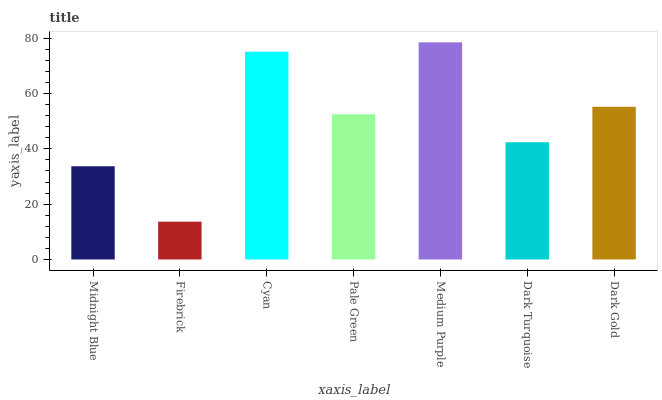Is Firebrick the minimum?
Answer yes or no. Yes. Is Medium Purple the maximum?
Answer yes or no. Yes. Is Cyan the minimum?
Answer yes or no. No. Is Cyan the maximum?
Answer yes or no. No. Is Cyan greater than Firebrick?
Answer yes or no. Yes. Is Firebrick less than Cyan?
Answer yes or no. Yes. Is Firebrick greater than Cyan?
Answer yes or no. No. Is Cyan less than Firebrick?
Answer yes or no. No. Is Pale Green the high median?
Answer yes or no. Yes. Is Pale Green the low median?
Answer yes or no. Yes. Is Cyan the high median?
Answer yes or no. No. Is Cyan the low median?
Answer yes or no. No. 